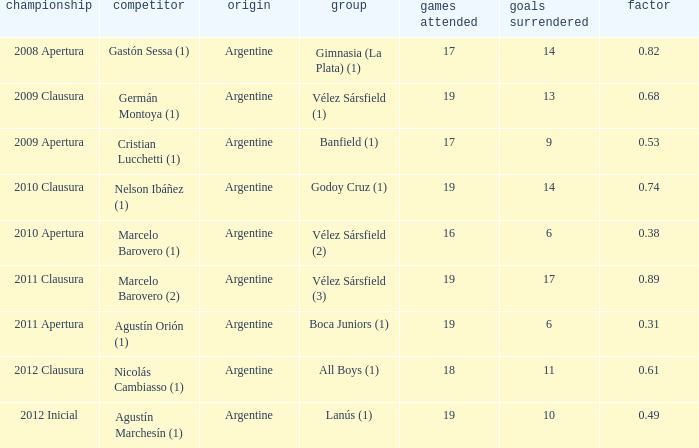Which team was in the 2012 clausura tournament? All Boys (1). 